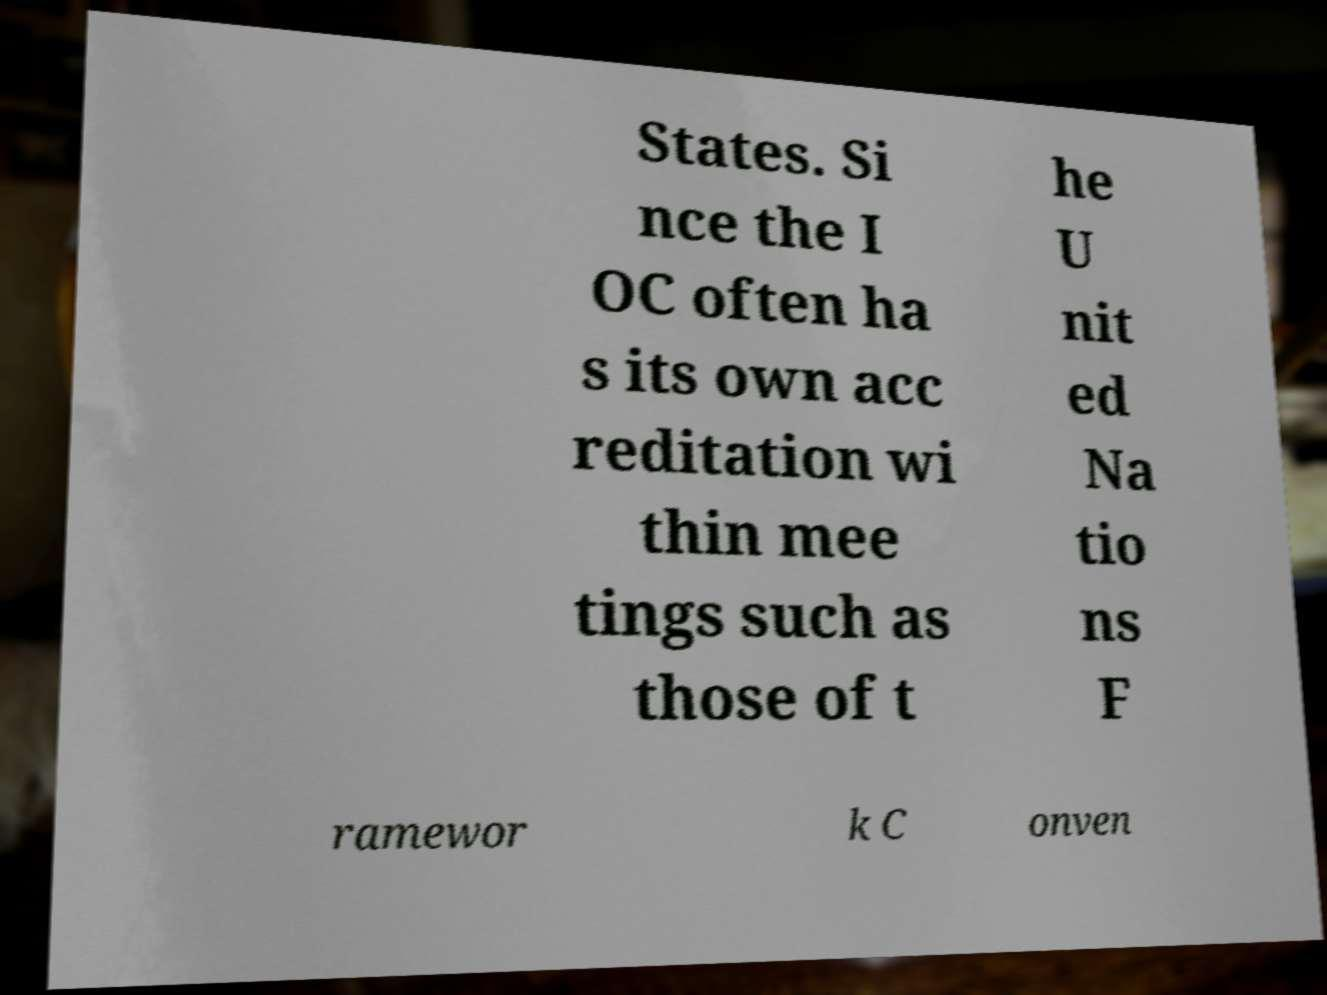There's text embedded in this image that I need extracted. Can you transcribe it verbatim? States. Si nce the I OC often ha s its own acc reditation wi thin mee tings such as those of t he U nit ed Na tio ns F ramewor k C onven 